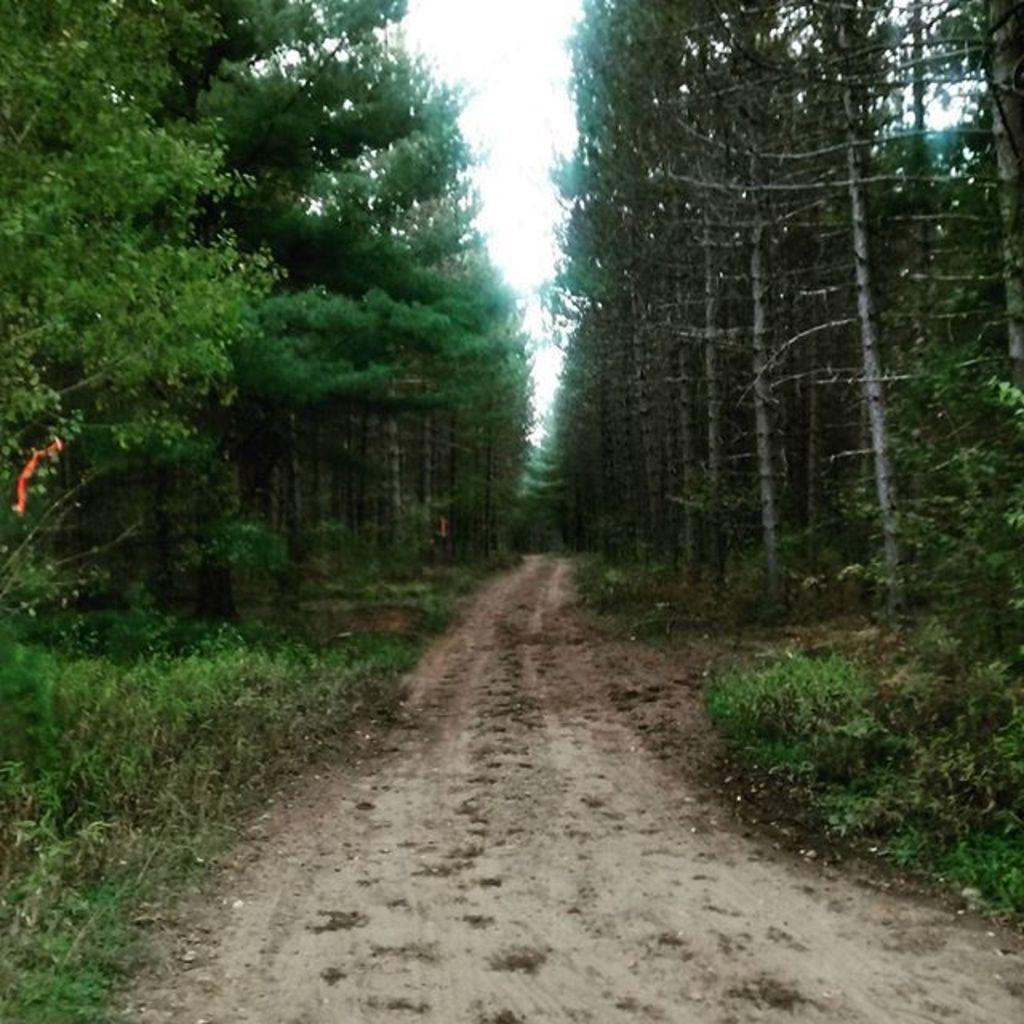What type of vegetation can be seen in the image? There are plants, trees, and grass in the image. What part of the natural environment is visible in the image? The sky is visible in the image. Can you see any ducks swimming in the ocean in the image? There is no ocean or ducks present in the image; it features plants, trees, grass, and the sky. 